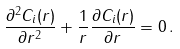<formula> <loc_0><loc_0><loc_500><loc_500>\frac { \partial ^ { 2 } C _ { i } ( r ) } { \partial r ^ { 2 } } + \frac { 1 } { r } \frac { \partial C _ { i } ( r ) } { \partial r } = 0 \, .</formula> 